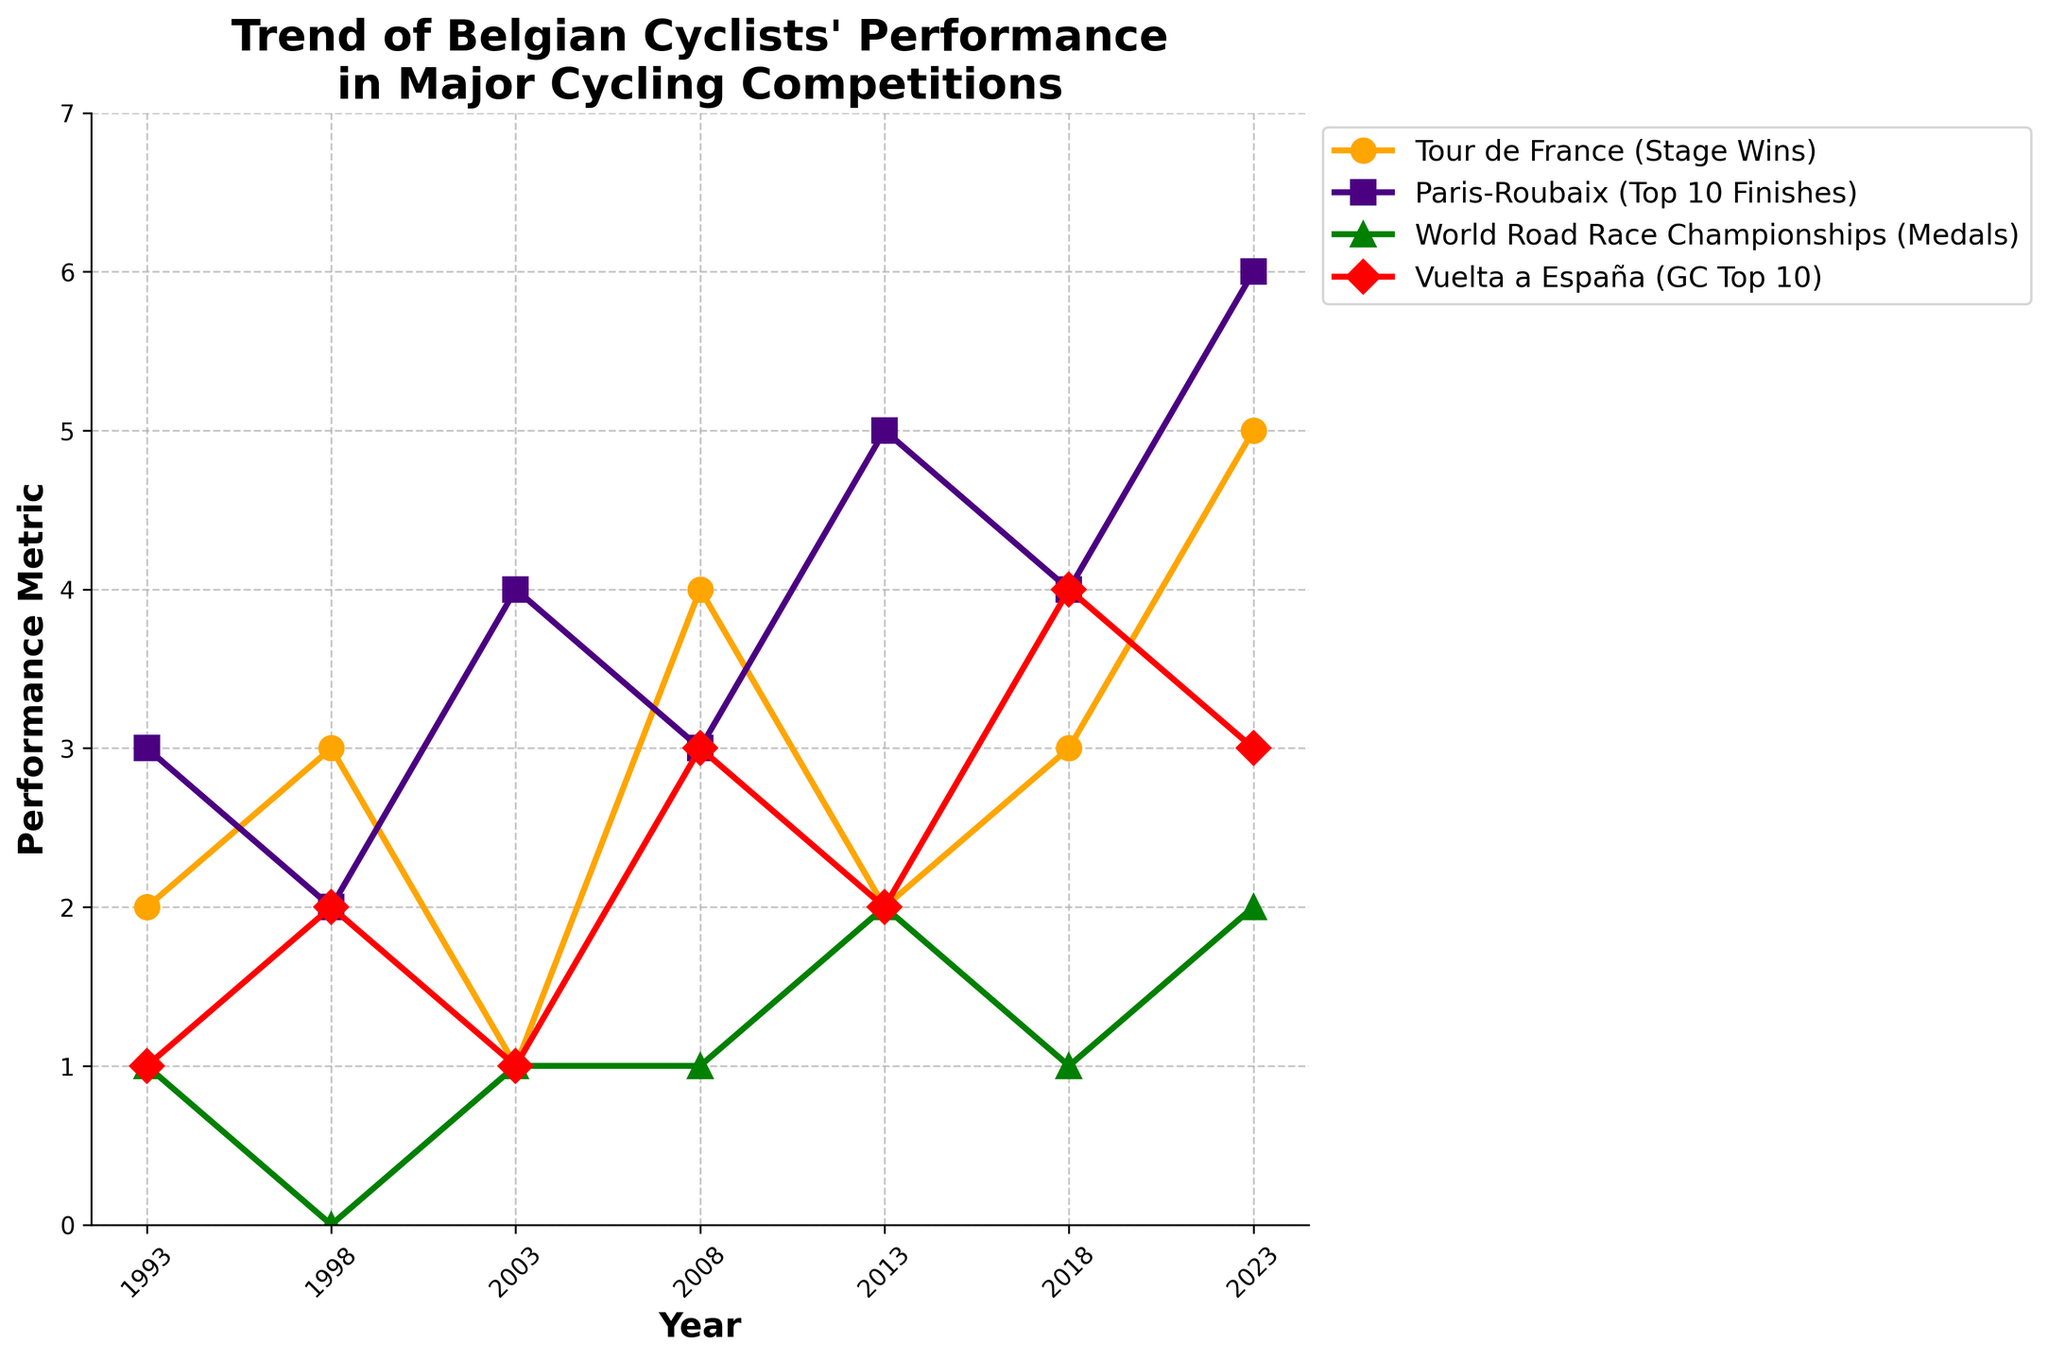What's the trend in the number of stage wins for Belgian cyclists in the Tour de France over the 30-year span? The line representing "Tour de France (Stage Wins)" in the chart generally shows an upward trend from 1993 to 2023, indicating increasing stage wins over this period.
Answer: Upward trend In which year did Belgian cyclists achieve the maximum number of top 10 finishes in Paris-Roubaix? The highest data point for "Paris-Roubaix (Top 10 Finishes)" on the chart is in the year 2023, with 6 top 10 finishes.
Answer: 2023 What is the average number of GC Top 10 finishes in Vuelta a España over the 30 years? Summing the values for "Vuelta a España (GC Top 10)" gives 16 (1+2+1+3+2+4+3). The average over 7 observations is 16/7.
Answer: ~2.29 Did Belgian cyclists win more stage wins in the Tour de France in 1998 or 2008? In 1998, they won 3 stage wins, whereas in 2008, they won 4.
Answer: 2008 How do the performance trends in Paris-Roubaix and World Road Race Championships compare visually? The "Paris-Roubaix (Top 10 Finishes)" line generally trends upwards, with some fluctuations. In contrast, the "World Road Race Championships (Medals)" line shows small fluctuations without a clear upward or downward trend.
Answer: Upward (Paris-Roubaix) vs Fluctuating (World Road Race) How many more medals were won in the World Road Race Championships in 2013 compared to 2003? In 2013, Belgian cyclists won 2 medals, whereas in 2003, they won 1. The difference is 2 - 1.
Answer: 1 more medal Which competition has the most consistent performance trend over the 30 years? The "Tour de France (Stage Wins)" trend shows the most consistent upward trend among all. Other competitions have more fluctuations and varied trends.
Answer: Tour de France On average, which competition has lower performance metrics: Paris-Roubaix or Vuelta a España? Calculating the average for Paris-Roubaix (3+2+4+3+5+4+6)/7 ≈ 3.86 and Vuelta a España (1+2+1+3+2+4+3)/7 ≈ 2.29 indicates that Vuelta a España has lower average performance metrics.
Answer: Vuelta a España In which year did Belgian cyclists achieve exactly one medal in the World Road Race Championships? The chart shows that in 1993, 2003, and 2008, Belgian cyclists won exactly 1 medal in the World Road Race Championships.
Answer: 1993, 2003, 2008 